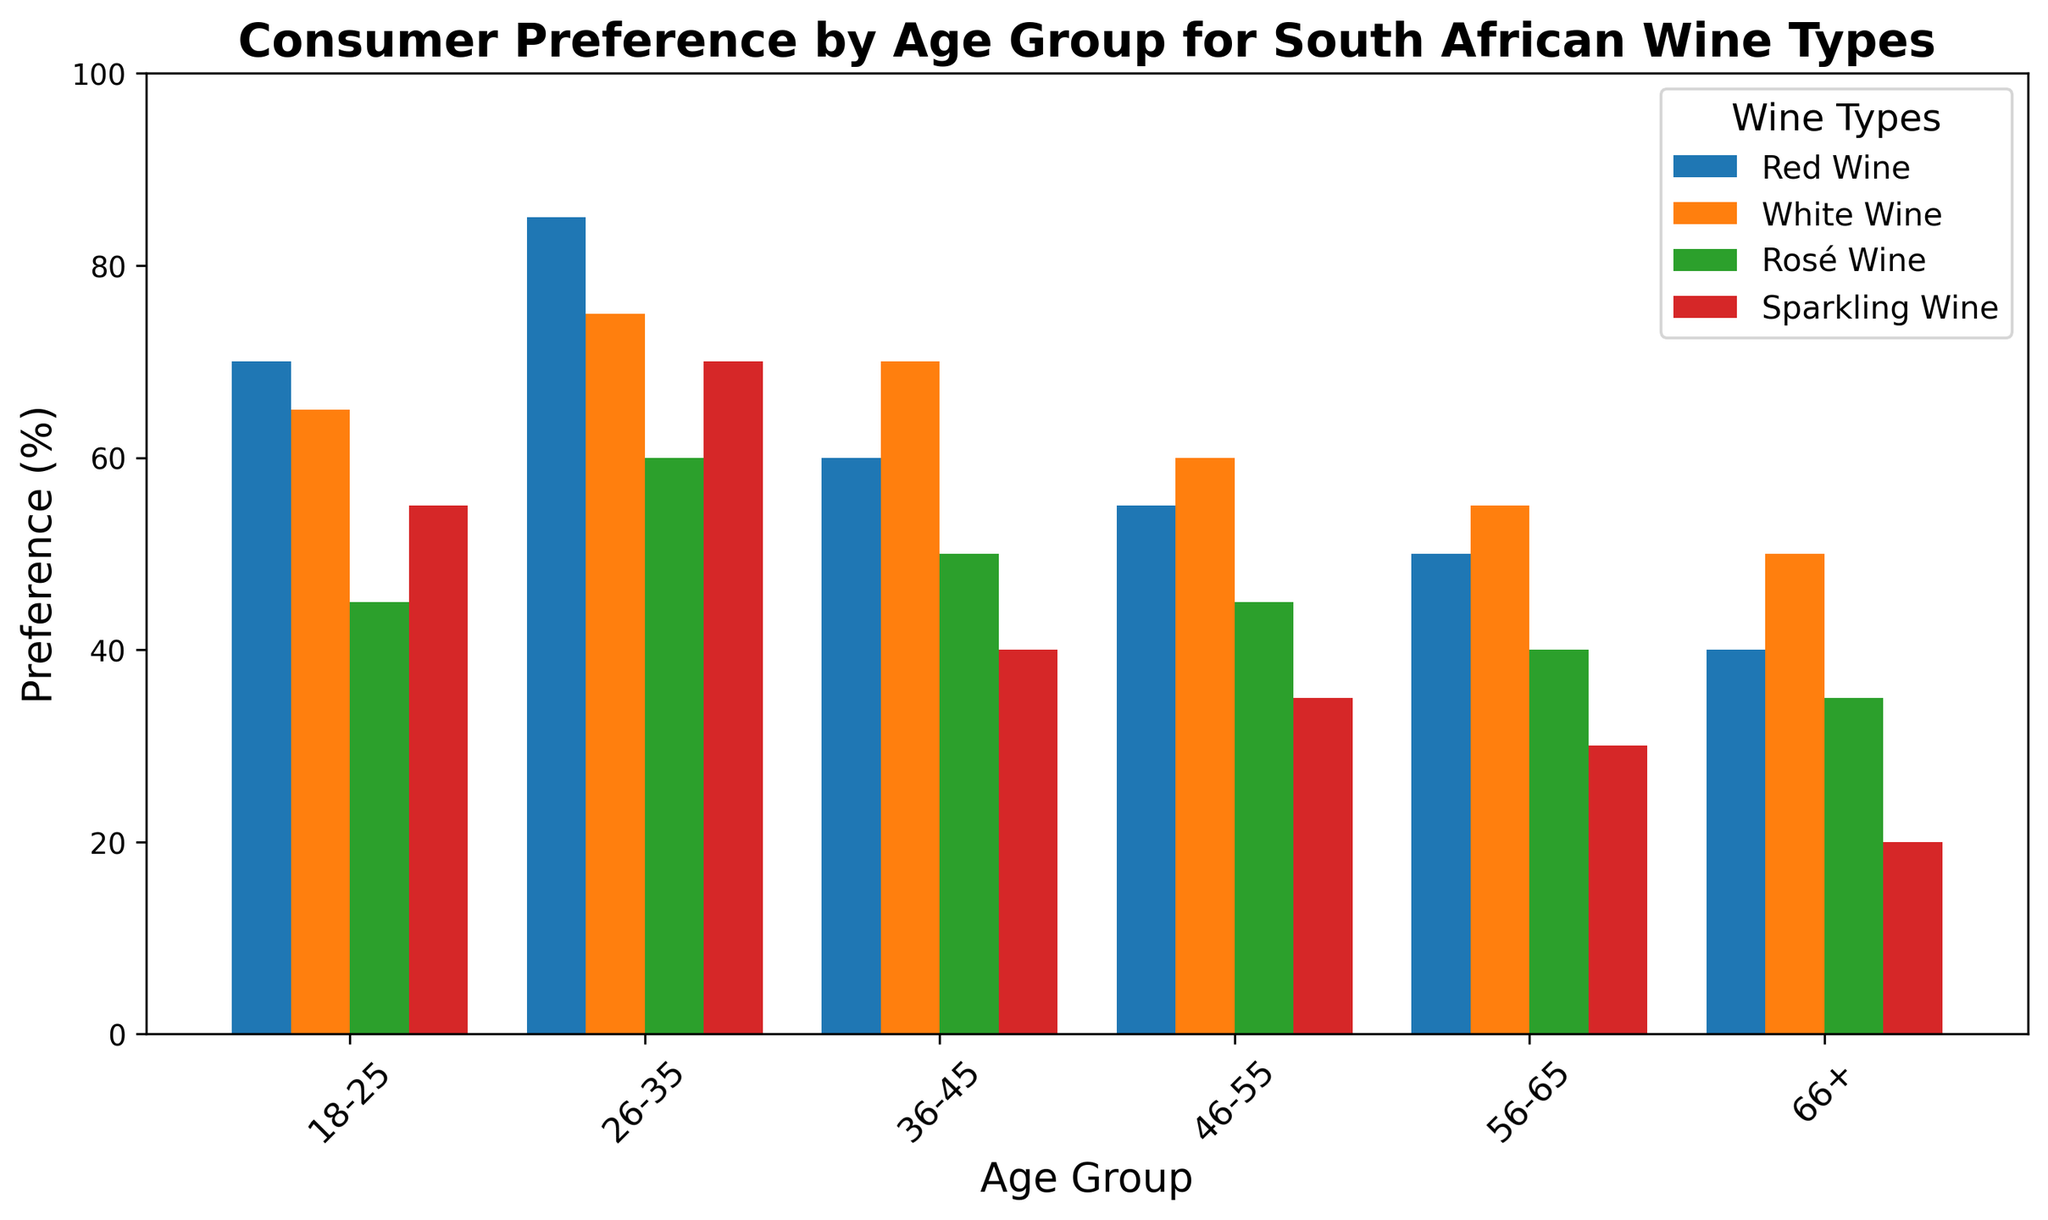What age group shows the highest preference for Red Wine? By observing the heights of the bars representing Red Wine across all age groups, we see that the age group 26-35 has the tallest bar.
Answer: 26-35 Which wine type is least preferred by the age group 66+? Checking the bars for the age group 66+, we find that the Sparkling Wine bar is the shortest among all wine types.
Answer: Sparkling Wine What's the difference between the highest and lowest preference for White Wine across all age groups? The highest preference for White Wine is 75% (age group 26-35), and the lowest is 50% (age group 66+). Subtracting these gives 75 - 50 = 25.
Answer: 25 Compare the preference for Rosé Wine between the age groups 18-25 and 56-65. Which group prefers it more, and by how much? The preference for Rosé Wine is 45% for the age group 18-25 and 40% for the age group 56-65. The group 18-25 prefers it more by 45 - 40 = 5.
Answer: 18-25, 5 What is the total preference percentage for all wine types combined for the age group 36-45? Adding the preferences for each wine type for the age group 36-45: 60 (Red Wine) + 70 (White Wine) + 50 (Rosé Wine) + 40 (Sparkling Wine) = 220.
Answer: 220 Identify the wine type with the greatest variation in preference percentages across the age groups. By comparing the range of preferences for each wine type, Red Wine has preferences ranging from 40% to 85%, the largest range of 45%.
Answer: Red Wine Which age group has the lowest overall preference for all wine types combined? Adding preferences for each wine type across all age groups, we find the age group 66+ has the lowest total of 40 (Red Wine) + 50 (White Wine) + 35 (Rosé Wine) + 20 (Sparkling Wine) = 145.
Answer: 66+ Determine the average preference for Sparkling Wine across all age groups. Adding the Sparkling Wine preferences and dividing by the number of age groups: (55 + 70 + 40 + 35 + 30 + 20) / 6 = 250 / 6 ≈ 41.67.
Answer: 41.67 